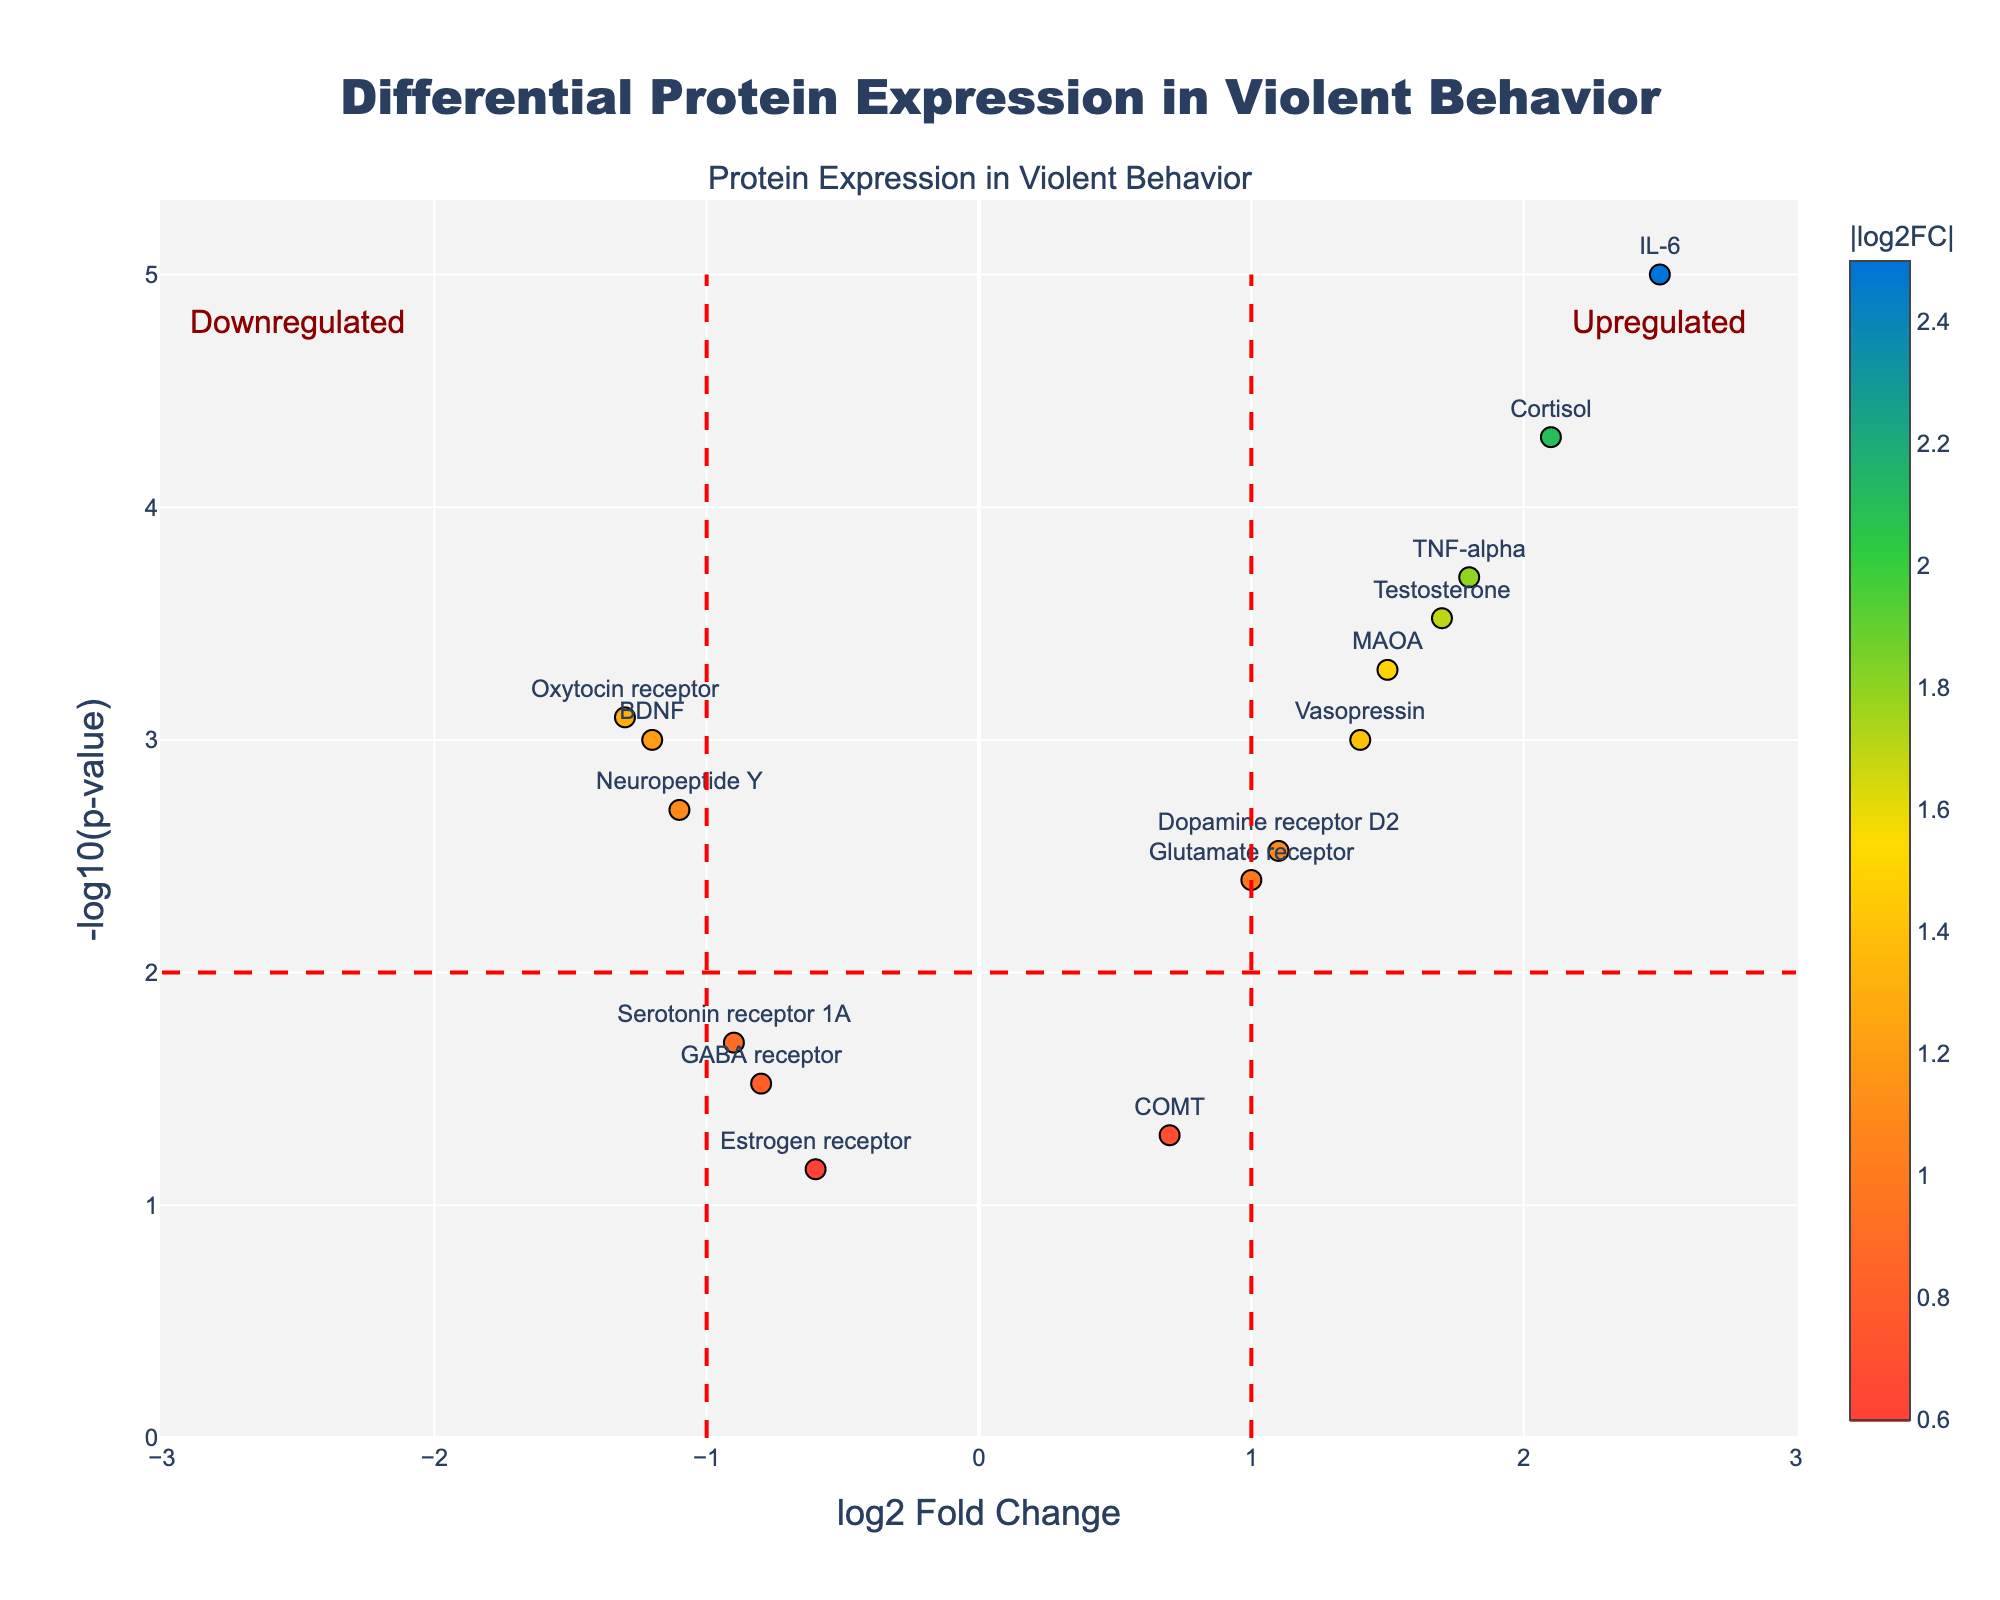What is the title of this plot? The title is located at the top center of the plot, usually giving a clear indication of what the plot represents. Here, it reads 'Differential Protein Expression in Violent Behavior'.
Answer: Differential Protein Expression in Violent Behavior What are the labels of the axes? The x-axis label is positioned below the horizontal axis, and the y-axis label is positioned beside the vertical axis. In this case, the x-axis is labeled 'log2 Fold Change' and the y-axis is labeled '-log10(p-value)'.
Answer: log2 Fold Change and -log10(p-value) What do the colors of the points represent? The colors of the points correspond to the absolute values of the log2 fold changes, indicated by the color bar legend on the plot. Higher values of absolute log2 fold change have different colors, ranging from red to dark blue.
Answer: Absolute values of log2 fold changes How many proteins show significant upregulation? Points with a log2 fold change greater than 1 and a -log10(p-value) greater than 2 are considered significantly upregulated. By examining these criteria, we identify the proteins above the threshold lines.
Answer: 5 Which protein is most upregulated? Identify the data point farthest to the right with the highest log2 fold change value. Here, IL-6 has the highest log2 fold change of 2.5.
Answer: IL-6 Which protein has the smallest p-value? The protein with the highest -log10(p-value) corresponds to the smallest p-value. Here, IL-6 has the highest -log10(p-value) value.
Answer: IL-6 Which protein is most downregulated? The protein furthest to the left with the lowest log2 fold change value indicates the most downregulation. In this plot, the Oxytocin receptor has the lowest log2 fold change of -1.3.
Answer: Oxytocin receptor How many proteins are shown in the plot? Count the total number of data points represented in the plot, corresponding to the number of proteins.
Answer: 15 Which protein has a log2 fold change closest to zero but still significant? Look for the point near the center (log2 fold change near 0) but above the significance threshold (-log10(p-value) > 2). Neuropeptide Y is closest to this criterion.
Answer: Neuropeptide Y Do any proteins show significant downregulation? Points with a log2 fold change less than -1 and a -log10(p-value) greater than 2 are considered significantly downregulated. By examining these criteria, we identify the proteins below the threshold lines.
Answer: Yes 